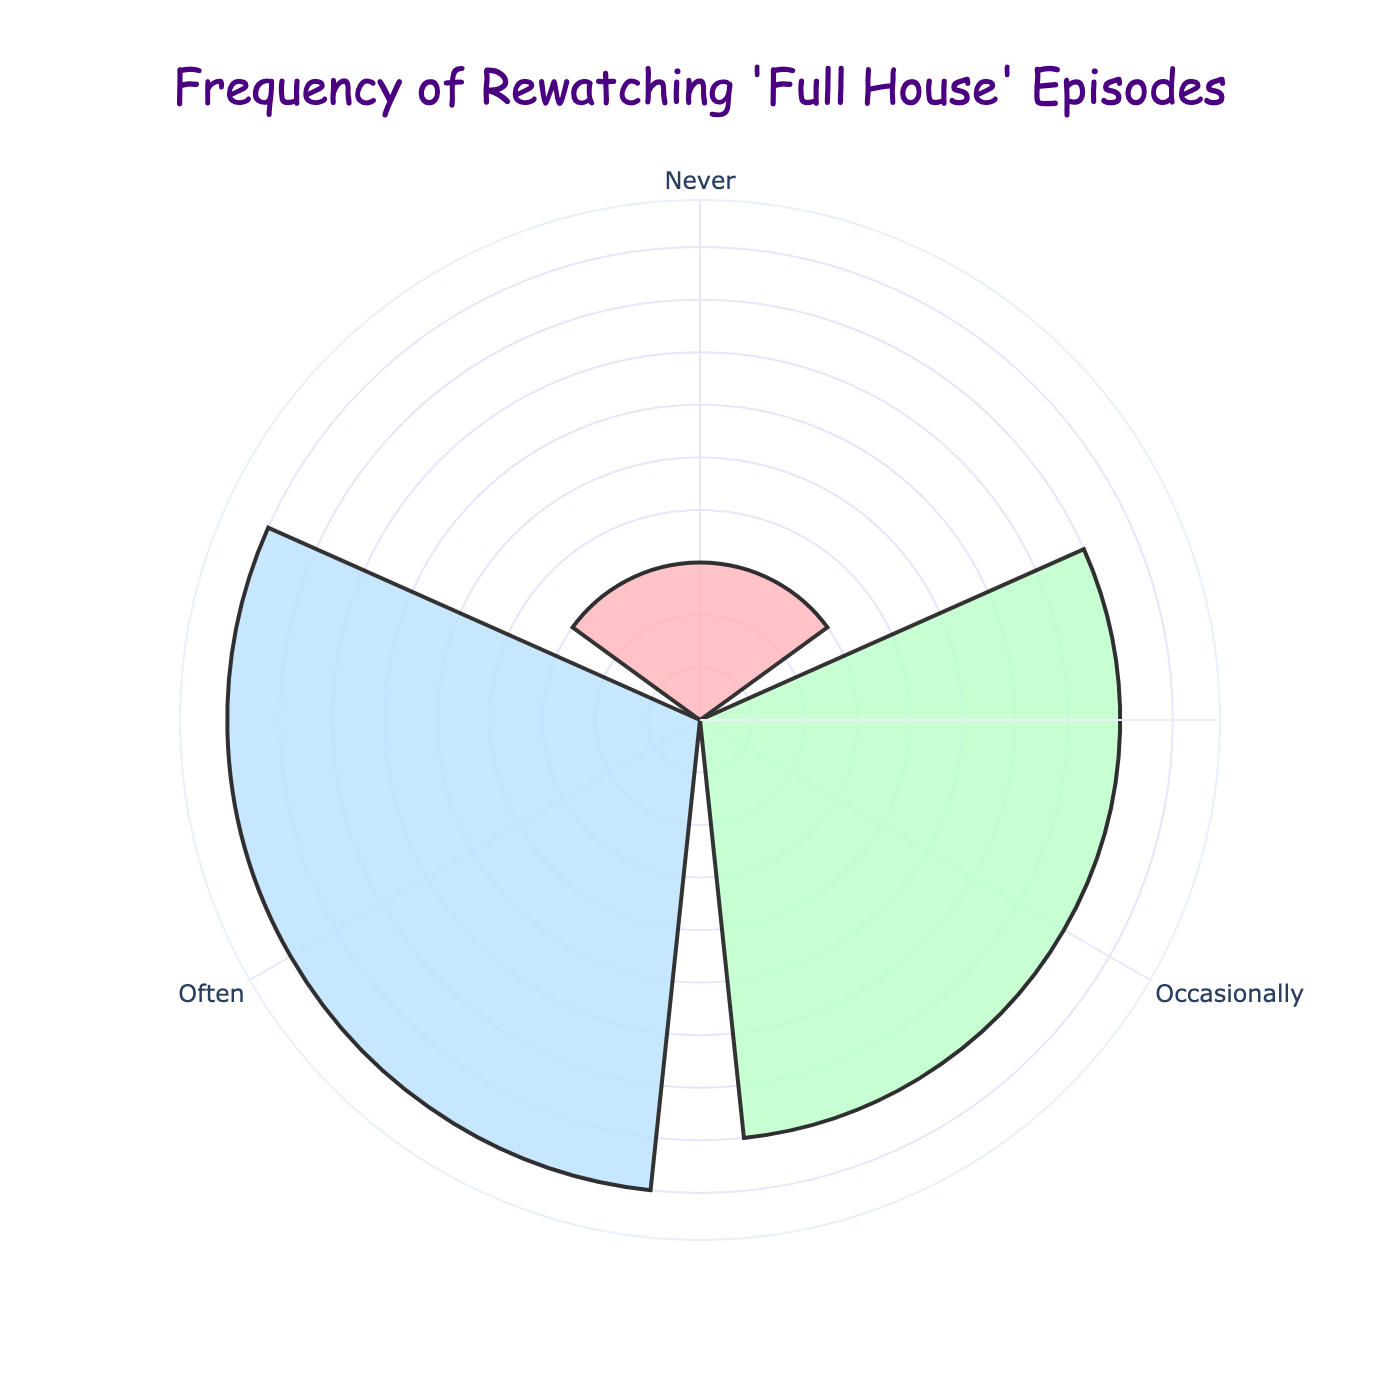what is the chart title? The chart title is explicitly displayed at the top of the figure and can be easily read as part of the visual elements.
Answer: Frequency of Rewatching 'Full House' Episodes how many categories are represented in the rose chart? The chart displays distinct segments with labels representing each category. Counting these segments gives the answer.
Answer: 3 which category has the highest frequency? Observing the length of the segments (bars) in the rose chart, the category with the longest bar represents the highest frequency.
Answer: Occasionally what is the sum of the frequencies for 'Never' and 'Often'? Finding the segments labeled 'Never' and 'Often' and noting their corresponding frequencies: 15 (Never) + 45 (Often).
Answer: 55 is the frequency for 'Never' greater than for 'Often'? Compare the lengths of the segments labeled 'Never' and 'Often' in the rose chart to determine which is larger.
Answer: No how does the frequency of 'Occasionally' compare to the total of 'Never' and 'Often'? The frequency of 'Occasionally' is 40. Summing up 'Never' (15) and 'Often' (45) gives 60. So, 'Occasionally' is less than the total of 'Never' and 'Often'.
Answer: Less what is the frequency of the group with the shortest bar? The shortest segment in the rose chart corresponds to the 'Never' category. Note its frequency value.
Answer: 15 which category's bar is at the top of the rose chart when rotating clockwise? Observing the topmost position of the segments when moving clockwise, the segment labeled 'Occasionally' appears first.
Answer: Occasionally how much greater is the frequency of 'Occasionally' compared to 'Always'? The frequency of 'Occasionally' is 40 and 'Always' (combined with 'Often') in the rose chart is 20. Subtracting 20 from 40 gives the difference.
Answer: 20 what percentage of the total does the 'Often' category represent? Calculate the total frequency: 15 + 40 + 45 = 100. 'Often' (including 'Always') is 45. Divide 45 by 100 and multiply by 100 to get the percentage.
Answer: 45% 